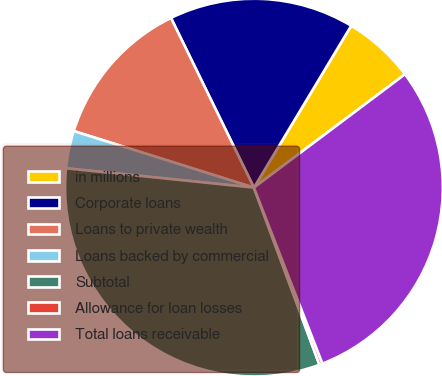Convert chart. <chart><loc_0><loc_0><loc_500><loc_500><pie_chart><fcel>in millions<fcel>Corporate loans<fcel>Loans to private wealth<fcel>Loans backed by commercial<fcel>Subtotal<fcel>Allowance for loan losses<fcel>Total loans receivable<nl><fcel>6.14%<fcel>15.85%<fcel>12.92%<fcel>3.21%<fcel>32.27%<fcel>0.27%<fcel>29.34%<nl></chart> 